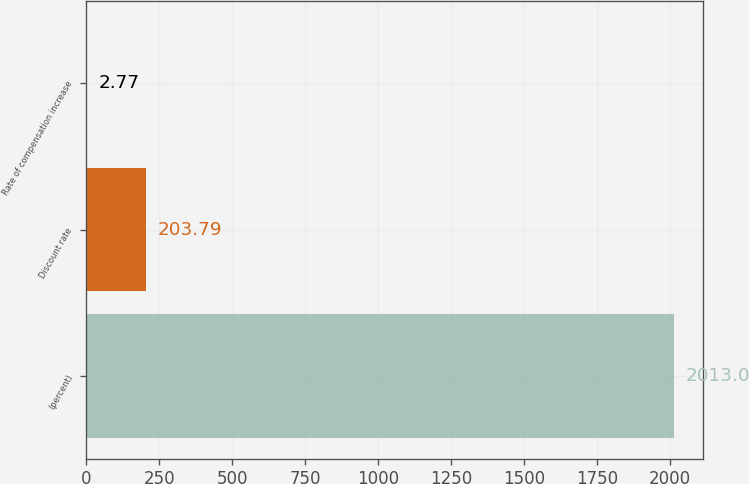Convert chart. <chart><loc_0><loc_0><loc_500><loc_500><bar_chart><fcel>(percent)<fcel>Discount rate<fcel>Rate of compensation increase<nl><fcel>2013<fcel>203.79<fcel>2.77<nl></chart> 